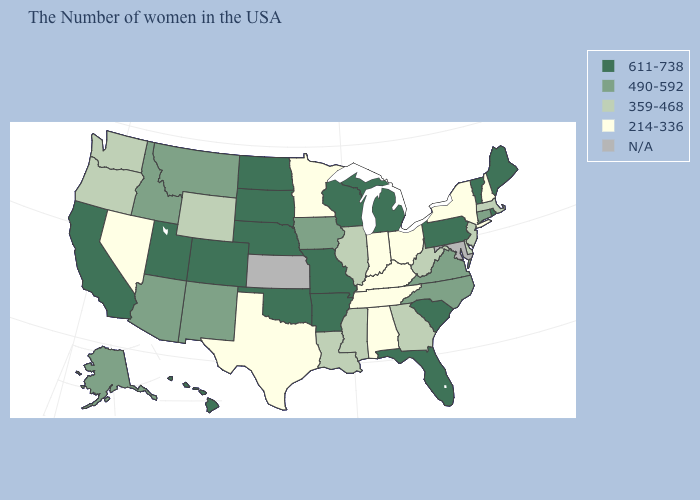What is the value of Colorado?
Write a very short answer. 611-738. What is the value of Texas?
Keep it brief. 214-336. Name the states that have a value in the range 359-468?
Be succinct. Massachusetts, New Jersey, Delaware, West Virginia, Georgia, Illinois, Mississippi, Louisiana, Wyoming, Washington, Oregon. Name the states that have a value in the range 490-592?
Quick response, please. Connecticut, Virginia, North Carolina, Iowa, New Mexico, Montana, Arizona, Idaho, Alaska. Does Massachusetts have the lowest value in the Northeast?
Be succinct. No. Does New Hampshire have the lowest value in the Northeast?
Short answer required. Yes. Which states hav the highest value in the Northeast?
Keep it brief. Maine, Rhode Island, Vermont, Pennsylvania. Which states have the highest value in the USA?
Be succinct. Maine, Rhode Island, Vermont, Pennsylvania, South Carolina, Florida, Michigan, Wisconsin, Missouri, Arkansas, Nebraska, Oklahoma, South Dakota, North Dakota, Colorado, Utah, California, Hawaii. Among the states that border Delaware , which have the highest value?
Quick response, please. Pennsylvania. What is the highest value in the USA?
Write a very short answer. 611-738. What is the value of Mississippi?
Quick response, please. 359-468. Does Alabama have the lowest value in the USA?
Be succinct. Yes. What is the lowest value in the South?
Answer briefly. 214-336. Name the states that have a value in the range N/A?
Keep it brief. Maryland, Kansas. 